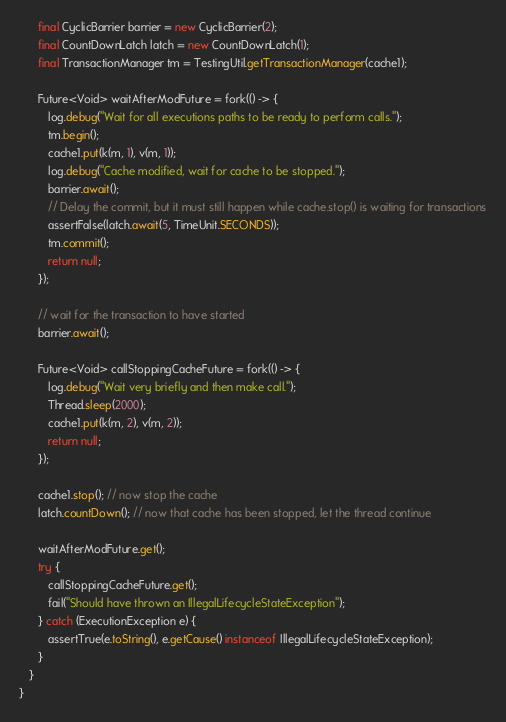Convert code to text. <code><loc_0><loc_0><loc_500><loc_500><_Java_>      final CyclicBarrier barrier = new CyclicBarrier(2);
      final CountDownLatch latch = new CountDownLatch(1);
      final TransactionManager tm = TestingUtil.getTransactionManager(cache1);

      Future<Void> waitAfterModFuture = fork(() -> {
         log.debug("Wait for all executions paths to be ready to perform calls.");
         tm.begin();
         cache1.put(k(m, 1), v(m, 1));
         log.debug("Cache modified, wait for cache to be stopped.");
         barrier.await();
         // Delay the commit, but it must still happen while cache.stop() is waiting for transactions
         assertFalse(latch.await(5, TimeUnit.SECONDS));
         tm.commit();
         return null;
      });

      // wait for the transaction to have started
      barrier.await();

      Future<Void> callStoppingCacheFuture = fork(() -> {
         log.debug("Wait very briefly and then make call.");
         Thread.sleep(2000);
         cache1.put(k(m, 2), v(m, 2));
         return null;
      });

      cache1.stop(); // now stop the cache
      latch.countDown(); // now that cache has been stopped, let the thread continue

      waitAfterModFuture.get();
      try {
         callStoppingCacheFuture.get();
         fail("Should have thrown an IllegalLifecycleStateException");
      } catch (ExecutionException e) {
         assertTrue(e.toString(), e.getCause() instanceof IllegalLifecycleStateException);
      }
   }
}
</code> 